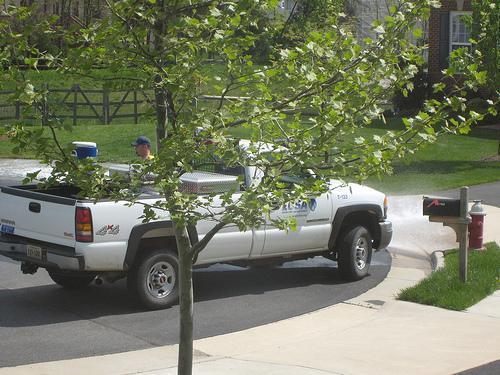How many vehicles are there?
Give a very brief answer. 1. How many people are in the picture?
Give a very brief answer. 1. 